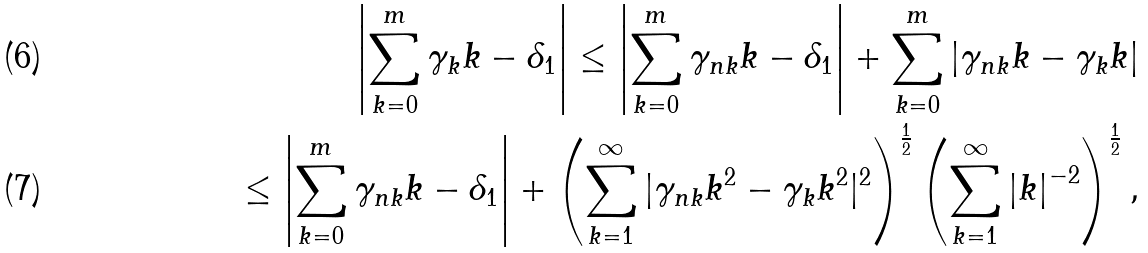<formula> <loc_0><loc_0><loc_500><loc_500>\left | \sum _ { k = 0 } ^ { m } \gamma _ { k } k - \delta _ { 1 } \right | \leq \left | \sum _ { k = 0 } ^ { m } \gamma _ { n k } k - \delta _ { 1 } \right | + \sum _ { k = 0 } ^ { m } | \gamma _ { n k } k - \gamma _ { k } k | \\ \leq \left | \sum _ { k = 0 } ^ { m } \gamma _ { n k } k - \delta _ { 1 } \right | + \left ( \sum _ { k = 1 } ^ { \infty } | \gamma _ { n k } k ^ { 2 } - \gamma _ { k } k ^ { 2 } | ^ { 2 } \right ) ^ { \frac { 1 } { 2 } } \left ( \sum _ { k = 1 } ^ { \infty } \left | k \right | ^ { - 2 } \right ) ^ { \frac { 1 } { 2 } } ,</formula> 